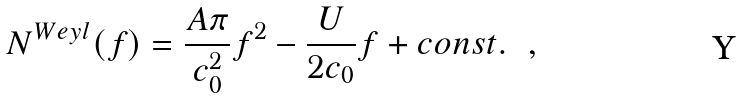Convert formula to latex. <formula><loc_0><loc_0><loc_500><loc_500>N ^ { W e y l } ( f ) = \frac { A \pi } { c ^ { 2 } _ { 0 } } f ^ { 2 } - \frac { U } { 2 c _ { 0 } } f + c o n s t . \ \ ,</formula> 